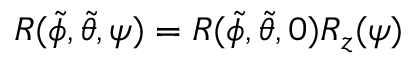<formula> <loc_0><loc_0><loc_500><loc_500>R ( \tilde { \phi } , \tilde { \theta } , \psi ) = R ( \tilde { \phi } , \tilde { \theta } , 0 ) R _ { z } ( \psi )</formula> 